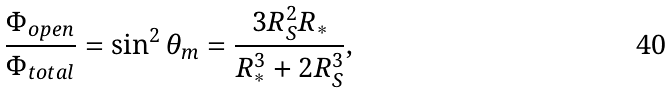Convert formula to latex. <formula><loc_0><loc_0><loc_500><loc_500>\frac { \Phi _ { o p e n } } { \Phi _ { t o t a l } } = \sin ^ { 2 } { \theta _ { m } } = \frac { 3 R _ { S } ^ { 2 } R _ { \ast } } { R _ { \ast } ^ { 3 } + 2 R _ { S } ^ { 3 } } ,</formula> 